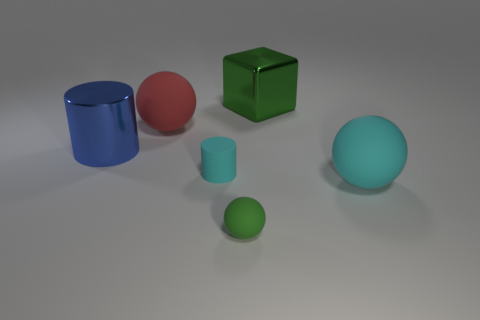Add 4 big green shiny objects. How many objects exist? 10 Subtract all cylinders. How many objects are left? 4 Subtract 0 red cylinders. How many objects are left? 6 Subtract all large gray cylinders. Subtract all green rubber balls. How many objects are left? 5 Add 6 large cubes. How many large cubes are left? 7 Add 3 big red objects. How many big red objects exist? 4 